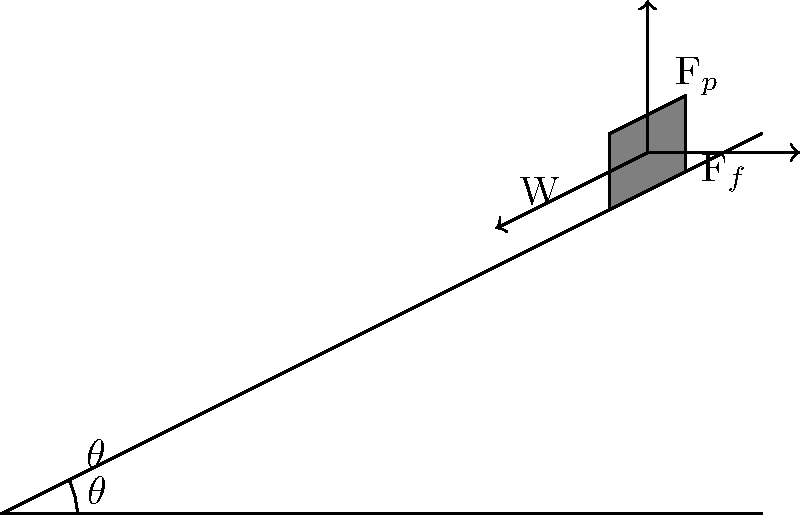You're pushing a loaded dolly up a ramp at a constant speed. The ramp makes an angle $\theta$ with the horizontal. If the weight of the loaded dolly is W, what is the magnitude of the pushing force $F_p$ required to move the dolly, assuming the coefficient of friction between the dolly and the ramp is $\mu$? To solve this problem, we'll follow these steps:

1) Identify the forces acting on the dolly:
   - Weight (W) acting downward
   - Normal force (N) perpendicular to the ramp
   - Friction force ($F_f$) parallel to the ramp, opposing motion
   - Pushing force ($F_p$) parallel to the ramp, in the direction of motion

2) Resolve the weight into components parallel and perpendicular to the ramp:
   - Weight parallel to ramp: $W \sin(\theta)$
   - Weight perpendicular to ramp: $W \cos(\theta)$

3) Apply Newton's Second Law for equilibrium (constant speed):
   - Parallel to ramp: $F_p - F_f - W \sin(\theta) = 0$
   - Perpendicular to ramp: $N - W \cos(\theta) = 0$

4) From the perpendicular equation: $N = W \cos(\theta)$

5) The friction force is given by: $F_f = \mu N = \mu W \cos(\theta)$

6) Substitute this into the parallel equation:
   $F_p - \mu W \cos(\theta) - W \sin(\theta) = 0$

7) Solve for $F_p$:
   $F_p = W(\mu \cos(\theta) + \sin(\theta))$

This equation gives us the magnitude of the pushing force required to move the dolly at constant speed up the ramp.
Answer: $F_p = W(\mu \cos(\theta) + \sin(\theta))$ 